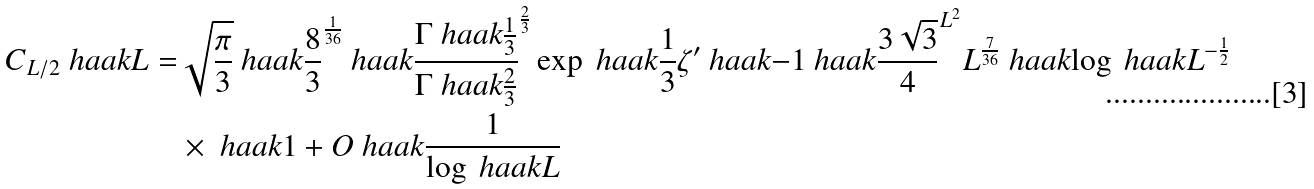Convert formula to latex. <formula><loc_0><loc_0><loc_500><loc_500>C _ { L / 2 } \ h a a k { L } = & \sqrt { \frac { \pi } { 3 } } \ h a a k { \frac { 8 } { 3 } } ^ { \frac { 1 } { 3 6 } } \ h a a k { \frac { \Gamma \ h a a k { \frac { 1 } { 3 } } } { \Gamma \ h a a k { \frac { 2 } { 3 } } } } ^ { \frac { 2 } { 3 } } \exp \ h a a k { \frac { 1 } { 3 } \zeta ^ { \prime } \ h a a k { - 1 } } \ h a a k { \frac { 3 \sqrt { 3 } } { 4 } } ^ { L ^ { 2 } } L ^ { \frac { 7 } { 3 6 } } \ h a a k { \log \ h a a k { L } } ^ { - \frac { 1 } { 2 } } \\ & \times \ h a a k { 1 + O \ h a a k { \frac { 1 } { \log \ h a a k { L } } } }</formula> 